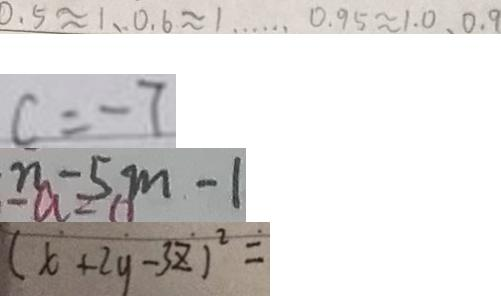<formula> <loc_0><loc_0><loc_500><loc_500>0 . 5 \approx 1 、 0 . 6 \approx 1 \cdots 0 . 9 5 \approx 1 . 0 、 0 . 9 
 c = - 7 
 n - 5 m - 1 
 ( x + 2 y - 3 z ) ^ { 2 } =</formula> 